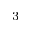Convert formula to latex. <formula><loc_0><loc_0><loc_500><loc_500>^ { 3 }</formula> 